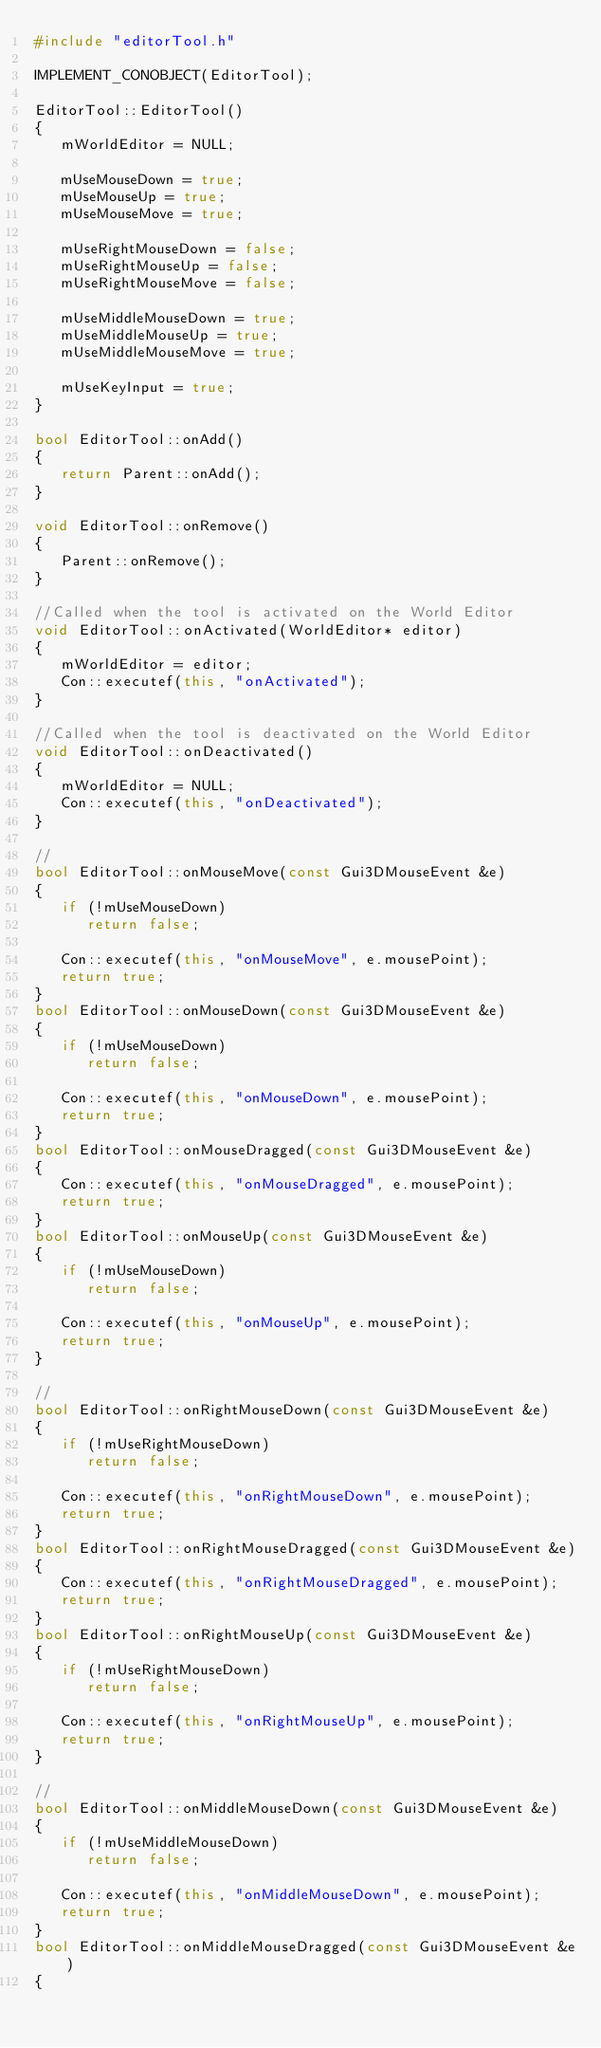Convert code to text. <code><loc_0><loc_0><loc_500><loc_500><_C++_>#include "editorTool.h"

IMPLEMENT_CONOBJECT(EditorTool);

EditorTool::EditorTool()
{
   mWorldEditor = NULL;

   mUseMouseDown = true;
   mUseMouseUp = true;
   mUseMouseMove = true;

   mUseRightMouseDown = false;
   mUseRightMouseUp = false;
   mUseRightMouseMove = false;

   mUseMiddleMouseDown = true;
   mUseMiddleMouseUp = true;
   mUseMiddleMouseMove = true;

   mUseKeyInput = true;
}

bool EditorTool::onAdd()
{
   return Parent::onAdd();
}

void EditorTool::onRemove()
{
   Parent::onRemove();
}

//Called when the tool is activated on the World Editor
void EditorTool::onActivated(WorldEditor* editor)
{
   mWorldEditor = editor;
   Con::executef(this, "onActivated");
}

//Called when the tool is deactivated on the World Editor
void EditorTool::onDeactivated()
{
   mWorldEditor = NULL;
   Con::executef(this, "onDeactivated");
}

//
bool EditorTool::onMouseMove(const Gui3DMouseEvent &e)
{
   if (!mUseMouseDown)
      return false;

   Con::executef(this, "onMouseMove", e.mousePoint);
   return true;
}
bool EditorTool::onMouseDown(const Gui3DMouseEvent &e)
{
   if (!mUseMouseDown)
      return false;

   Con::executef(this, "onMouseDown", e.mousePoint);
   return true;
}
bool EditorTool::onMouseDragged(const Gui3DMouseEvent &e)
{
   Con::executef(this, "onMouseDragged", e.mousePoint);
   return true;
}
bool EditorTool::onMouseUp(const Gui3DMouseEvent &e)
{
   if (!mUseMouseDown)
      return false;

   Con::executef(this, "onMouseUp", e.mousePoint);
   return true;
}

//
bool EditorTool::onRightMouseDown(const Gui3DMouseEvent &e)
{
   if (!mUseRightMouseDown)
      return false;

   Con::executef(this, "onRightMouseDown", e.mousePoint);
   return true;
}
bool EditorTool::onRightMouseDragged(const Gui3DMouseEvent &e)
{
   Con::executef(this, "onRightMouseDragged", e.mousePoint);
   return true;
}
bool EditorTool::onRightMouseUp(const Gui3DMouseEvent &e)
{
   if (!mUseRightMouseDown)
      return false;

   Con::executef(this, "onRightMouseUp", e.mousePoint);
   return true;
}

//
bool EditorTool::onMiddleMouseDown(const Gui3DMouseEvent &e)
{
   if (!mUseMiddleMouseDown)
      return false;

   Con::executef(this, "onMiddleMouseDown", e.mousePoint);
   return true;
}
bool EditorTool::onMiddleMouseDragged(const Gui3DMouseEvent &e)
{</code> 